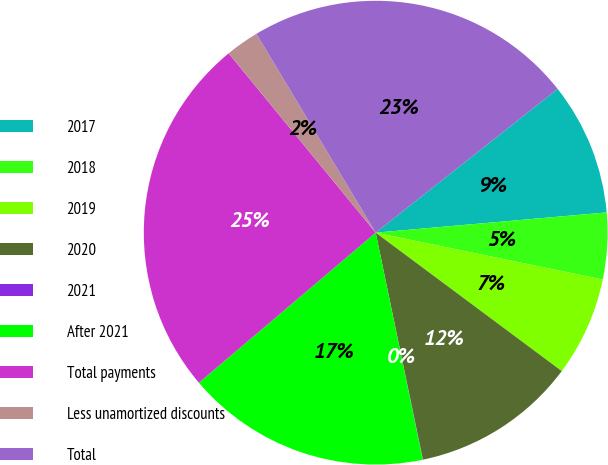<chart> <loc_0><loc_0><loc_500><loc_500><pie_chart><fcel>2017<fcel>2018<fcel>2019<fcel>2020<fcel>2021<fcel>After 2021<fcel>Total payments<fcel>Less unamortized discounts<fcel>Total<nl><fcel>9.25%<fcel>4.63%<fcel>6.94%<fcel>11.55%<fcel>0.02%<fcel>17.05%<fcel>25.27%<fcel>2.33%<fcel>22.96%<nl></chart> 